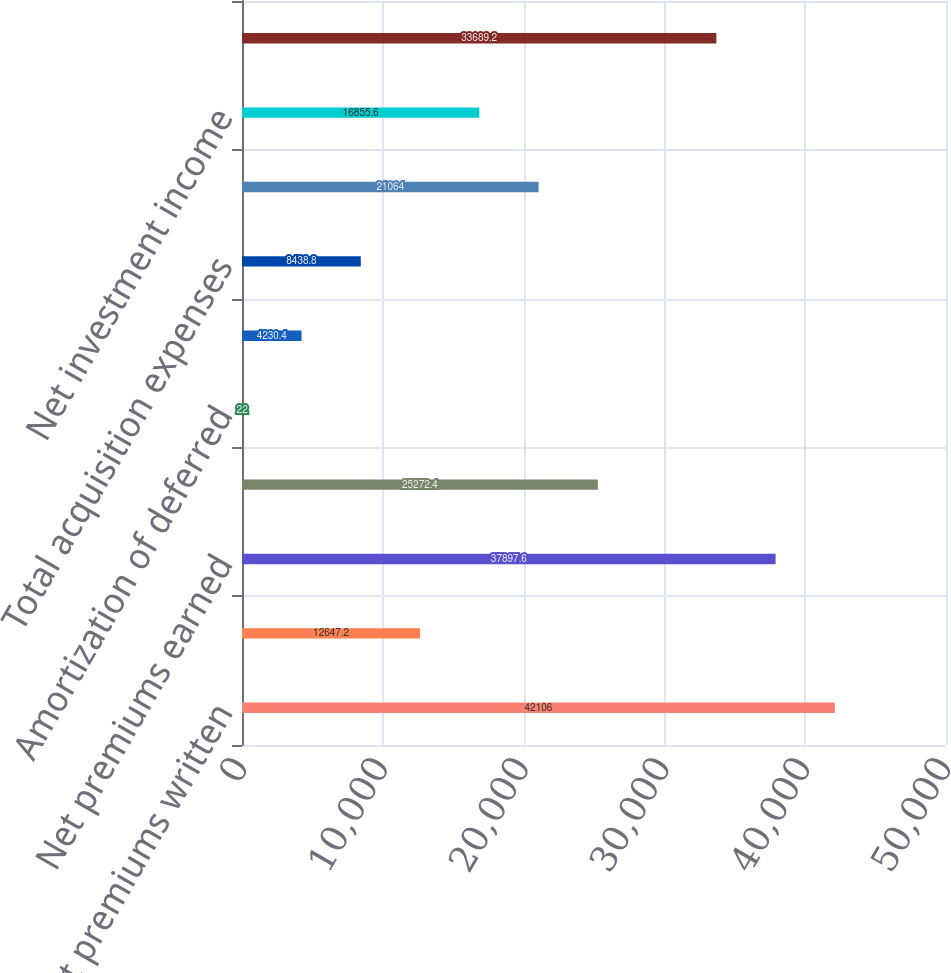<chart> <loc_0><loc_0><loc_500><loc_500><bar_chart><fcel>Net premiums written<fcel>Increase in unearned premiums<fcel>Net premiums earned<fcel>Losses and loss adjustment<fcel>Amortization of deferred<fcel>Other acquisition expenses<fcel>Total acquisition expenses<fcel>General operating expenses<fcel>Net investment income<fcel>Pre-tax operating income<nl><fcel>42106<fcel>12647.2<fcel>37897.6<fcel>25272.4<fcel>22<fcel>4230.4<fcel>8438.8<fcel>21064<fcel>16855.6<fcel>33689.2<nl></chart> 